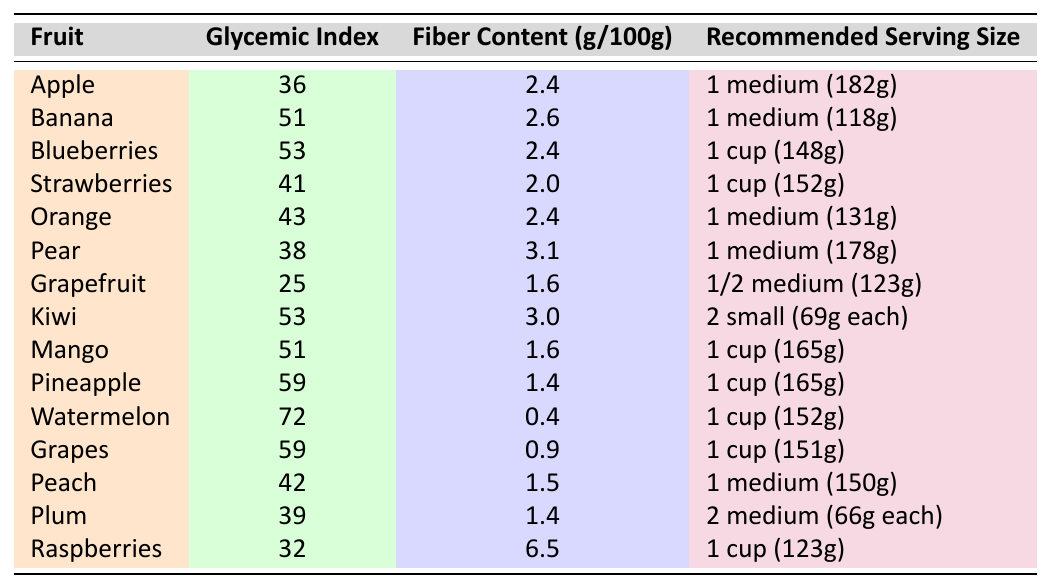What is the glycemic index of an apple? The table shows that the glycemic index for apple is listed under the corresponding column, which is 36.
Answer: 36 Which fruit has the highest fiber content per 100g? Looking through the fiber content column, I see that raspberries have a fiber content of 6.5g, which is greater than all the other entries.
Answer: Raspberries What is the recommended serving size for a kiwi? The table lists the recommended serving size for kiwi as "2 small (69g each)."
Answer: 2 small (69g each) Are grapes high in fiber compared to other fruits in this table? By checking the fiber content for grapes, which is 0.9g per 100g, I can compare it with other fruits. Fruits like raspberries and pears have much higher fiber contents, indicating that grapes are relatively low in fiber.
Answer: No What is the average glycemic index of the fruits listed in the table? To find the average, I first add the glycemic indices: 36 + 51 + 53 + 41 + 43 + 38 + 25 + 53 + 51 + 59 + 72 + 59 + 42 + 39 + 32 = 732. There are 15 fruits, so I divide 732 by 15, which gives approximately 48.8.
Answer: 48.8 Which fruit has the lowest glycemic index and what is it? The lowest glycemic index in the table belongs to grapefruit, which has an index of 25.
Answer: Grapefruit, 25 If I want a snack that balances low glycemic index and high fiber content, which fruit should I consider? Raspberries have the lowest glycemic index of 32 while also having the highest fiber content of 6.5g per 100g, making them a strong candidate for a balanced snack.
Answer: Raspberries How does the glycemic index of bananas compare to that of pears? Bananas have a glycemic index of 51, whereas pears have an index of 38. Thus, pears have a lower glycemic index than bananas.
Answer: Pears have a lower glycemic index What is the total fiber content in a medium apple and a medium orange combined? The fiber content of an apple is 2.4g and for an orange is also 2.4g. Summing them up gives 2.4 + 2.4 = 4.8g.
Answer: 4.8g Are the glycemic indices of mango and pineapple the same? By checking the table, mango has a glycemic index of 51, while pineapple has an index of 59, thus they are not the same.
Answer: No, they are not the same 